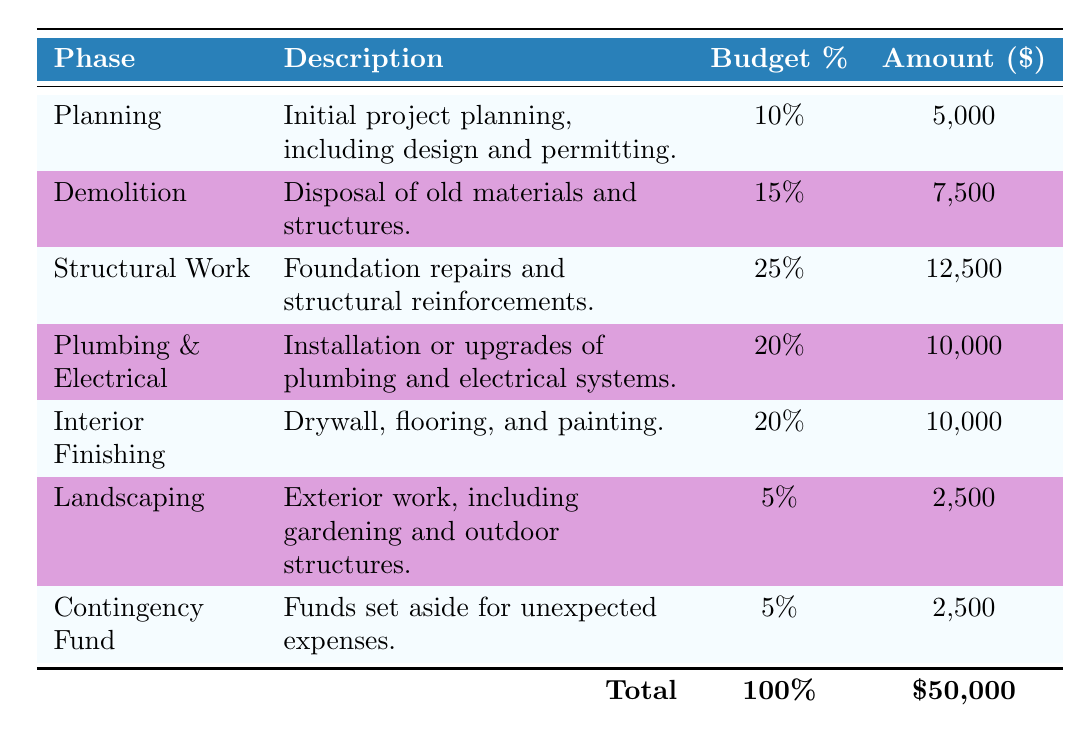What is the budget percentage allocated for Demolition? The table specifies the budget percentage for the Demolition phase, which is directly stated as 15% in the relevant row.
Answer: 15% What is the amount budgeted for Landscaping? The table lists the amount allocated for Landscaping in the corresponding row as $2,500.
Answer: $2,500 Which phase has the highest budget allocation percentage? By reviewing the budget percentages in the table, Structural Work has the highest allocation at 25%.
Answer: Structural Work Is the budget amount for Interior Finishing equal to that for Plumbing & Electrical? The table shows that both Interior Finishing and Plumbing & Electrical have the same budget amount of $10,000, so they are equal.
Answer: Yes What is the total budget amount allocated for all phases combined? The total budget amount can be found in the table, where it summarizes the total as $50,000 at the bottom.
Answer: $50,000 What percentage of the total budget is allocated to the Contingency Fund? The table indicates that the Contingency Fund has a budget percentage of 5%, which represents its share of the total budget.
Answer: 5% How much more is allocated to Structural Work compared to Landscaping? The budget amount for Structural Work is $12,500 and for Landscaping is $2,500. The difference is calculated by subtracting the Landscaping amount from the Structural Work amount: $12,500 - $2,500 = $10,000.
Answer: $10,000 What phase accounts for the least budget percentage? By examining the percentages in the table, it's clear that Landscaping and Contingency Fund each have the smallest budget percentage of 5%.
Answer: Landscaping and Contingency Fund If we combine the budgets for Planning and Demolition, what total amount is that? The budget amounts for Planning ($5,000) and Demolition ($7,500) are added together: $5,000 + $7,500 = $12,500.
Answer: $12,500 Which two phases together account for 30% of the total budget? Checking the budget percentages, Structural Work (25%) and Landscaping (5%) combine to make 30%. The sum is 25% + 5% = 30%.
Answer: Structural Work and Landscaping 